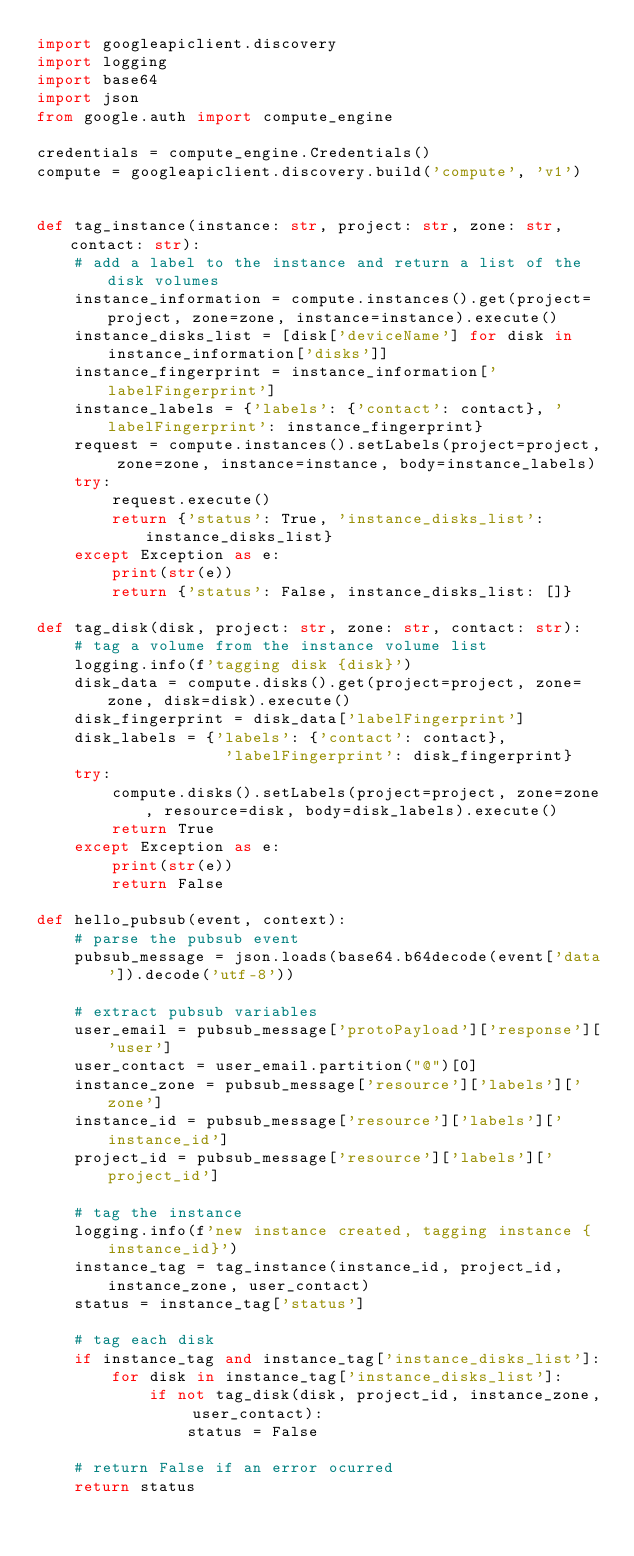<code> <loc_0><loc_0><loc_500><loc_500><_Python_>import googleapiclient.discovery
import logging
import base64
import json
from google.auth import compute_engine

credentials = compute_engine.Credentials()
compute = googleapiclient.discovery.build('compute', 'v1')


def tag_instance(instance: str, project: str, zone: str, contact: str):
    # add a label to the instance and return a list of the disk volumes
    instance_information = compute.instances().get(project=project, zone=zone, instance=instance).execute()
    instance_disks_list = [disk['deviceName'] for disk in instance_information['disks']]
    instance_fingerprint = instance_information['labelFingerprint']
    instance_labels = {'labels': {'contact': contact}, 'labelFingerprint': instance_fingerprint}
    request = compute.instances().setLabels(project=project, zone=zone, instance=instance, body=instance_labels)
    try:
        request.execute()
        return {'status': True, 'instance_disks_list': instance_disks_list}
    except Exception as e:
        print(str(e))
        return {'status': False, instance_disks_list: []}

def tag_disk(disk, project: str, zone: str, contact: str):
    # tag a volume from the instance volume list
    logging.info(f'tagging disk {disk}')
    disk_data = compute.disks().get(project=project, zone=zone, disk=disk).execute()
    disk_fingerprint = disk_data['labelFingerprint']
    disk_labels = {'labels': {'contact': contact},
                    'labelFingerprint': disk_fingerprint}
    try:
        compute.disks().setLabels(project=project, zone=zone, resource=disk, body=disk_labels).execute()
        return True
    except Exception as e:
        print(str(e))
        return False

def hello_pubsub(event, context):
    # parse the pubsub event
    pubsub_message = json.loads(base64.b64decode(event['data']).decode('utf-8'))

    # extract pubsub variables
    user_email = pubsub_message['protoPayload']['response']['user']
    user_contact = user_email.partition("@")[0]
    instance_zone = pubsub_message['resource']['labels']['zone']
    instance_id = pubsub_message['resource']['labels']['instance_id']
    project_id = pubsub_message['resource']['labels']['project_id']

    # tag the instance
    logging.info(f'new instance created, tagging instance {instance_id}')
    instance_tag = tag_instance(instance_id, project_id, instance_zone, user_contact)
    status = instance_tag['status']

    # tag each disk
    if instance_tag and instance_tag['instance_disks_list']:
        for disk in instance_tag['instance_disks_list']:
            if not tag_disk(disk, project_id, instance_zone, user_contact):
                status = False

    # return False if an error ocurred
    return status
</code> 